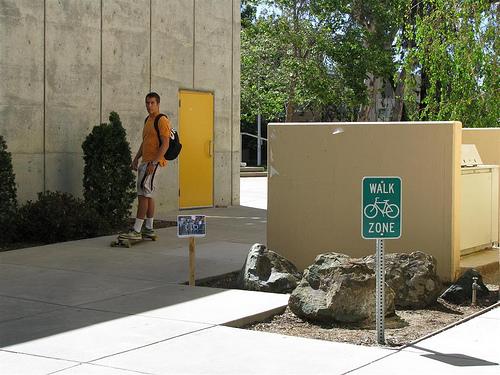What color is the door?
Concise answer only. Yellow. What language is on the signs?
Short answer required. English. What does the green sign say?
Be succinct. Walk zone. What does the blue sign say?
Keep it brief. Walk zone. Is the sign contradicting?
Concise answer only. Yes. How many bicycles are there?
Give a very brief answer. 0. 